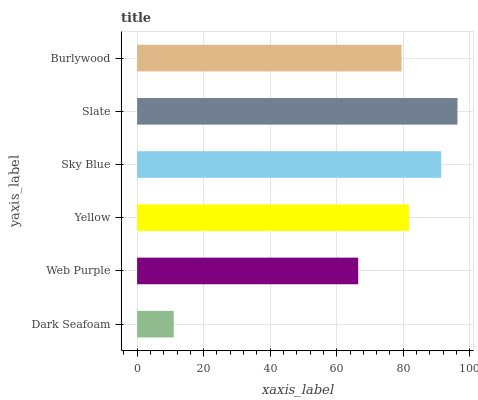Is Dark Seafoam the minimum?
Answer yes or no. Yes. Is Slate the maximum?
Answer yes or no. Yes. Is Web Purple the minimum?
Answer yes or no. No. Is Web Purple the maximum?
Answer yes or no. No. Is Web Purple greater than Dark Seafoam?
Answer yes or no. Yes. Is Dark Seafoam less than Web Purple?
Answer yes or no. Yes. Is Dark Seafoam greater than Web Purple?
Answer yes or no. No. Is Web Purple less than Dark Seafoam?
Answer yes or no. No. Is Yellow the high median?
Answer yes or no. Yes. Is Burlywood the low median?
Answer yes or no. Yes. Is Slate the high median?
Answer yes or no. No. Is Slate the low median?
Answer yes or no. No. 